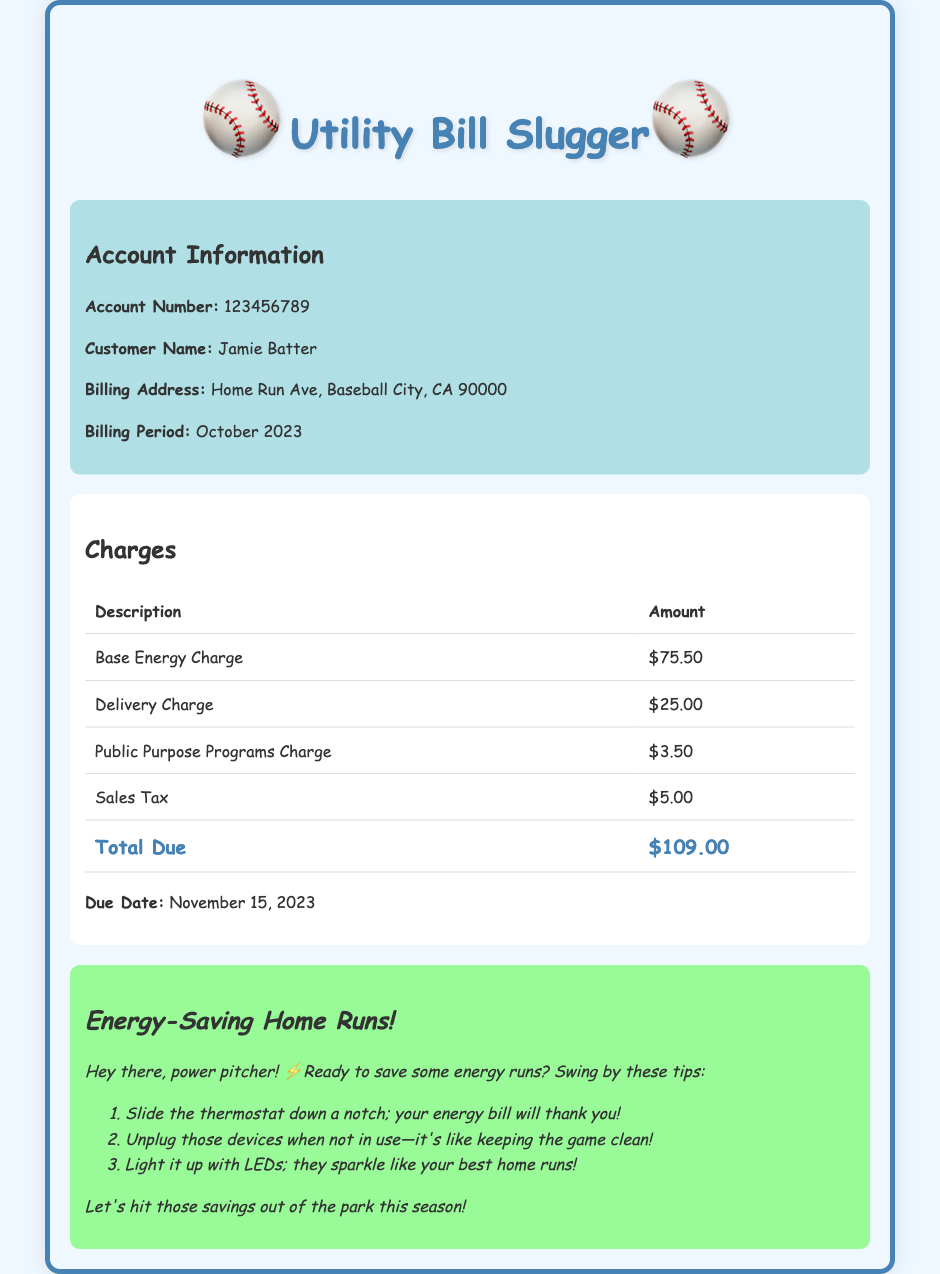what is the account number? The account number is specified in the account information section of the document.
Answer: 123456789 who is the customer name? The document lists the name of the customer in the account information section.
Answer: Jamie Batter what is the billing address? The billing address is provided in the account information section of the document.
Answer: Home Run Ave, Baseball City, CA 90000 what is the total due? The total due is highlighted in the charges section as the overall amount to be paid.
Answer: $109.00 when is the due date? The due date is stated in the charges section, informing the customer when payment is required.
Answer: November 15, 2023 how much is the base energy charge? The base energy charge is listed in the detailed charges breakdown table.
Answer: $75.50 what is one energy-saving tip mentioned? The document provides a list of energy-saving tips under the playful message section.
Answer: Slide the thermostat down a notch; your energy bill will thank you! what type of document is this? The document is a utility bill, which is evident from the title and content structure.
Answer: Utility Bill how many charges are listed? The number of charges can be counted in the charges table presented in the document.
Answer: 4 